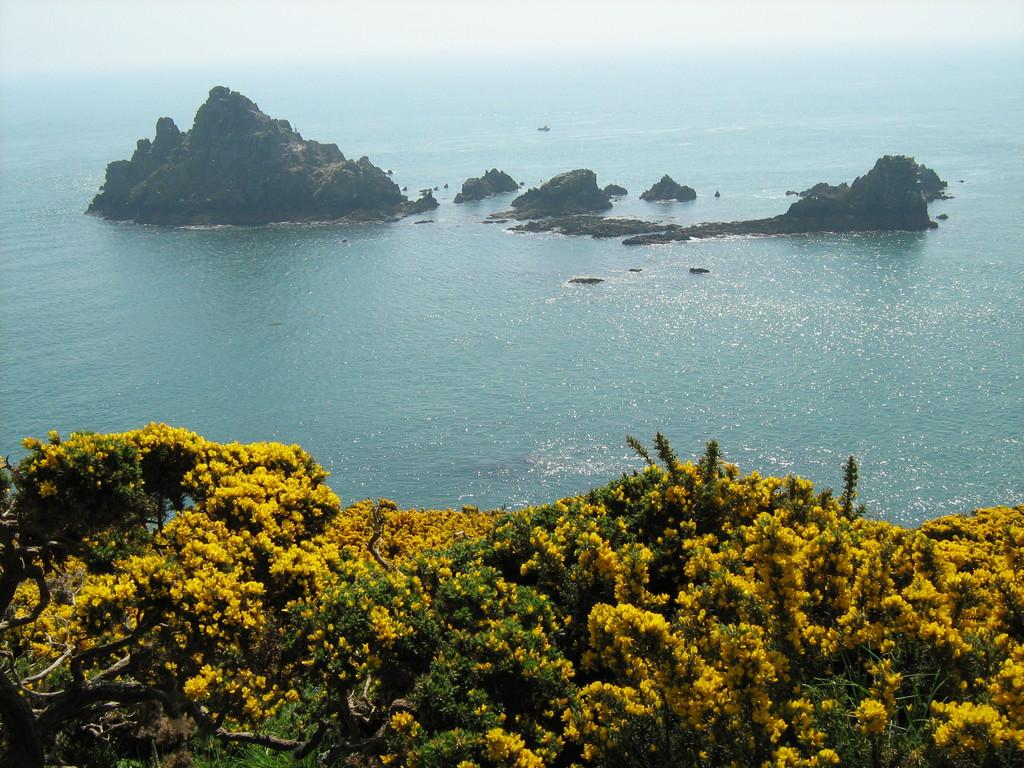What type of vegetation is present in the image? There are trees with flowers in the image. What can be seen in the water in the image? There are rocks visible in the water in the image. How many kittens are swimming in the ocean in the image? There is no ocean or kittens present in the image. 